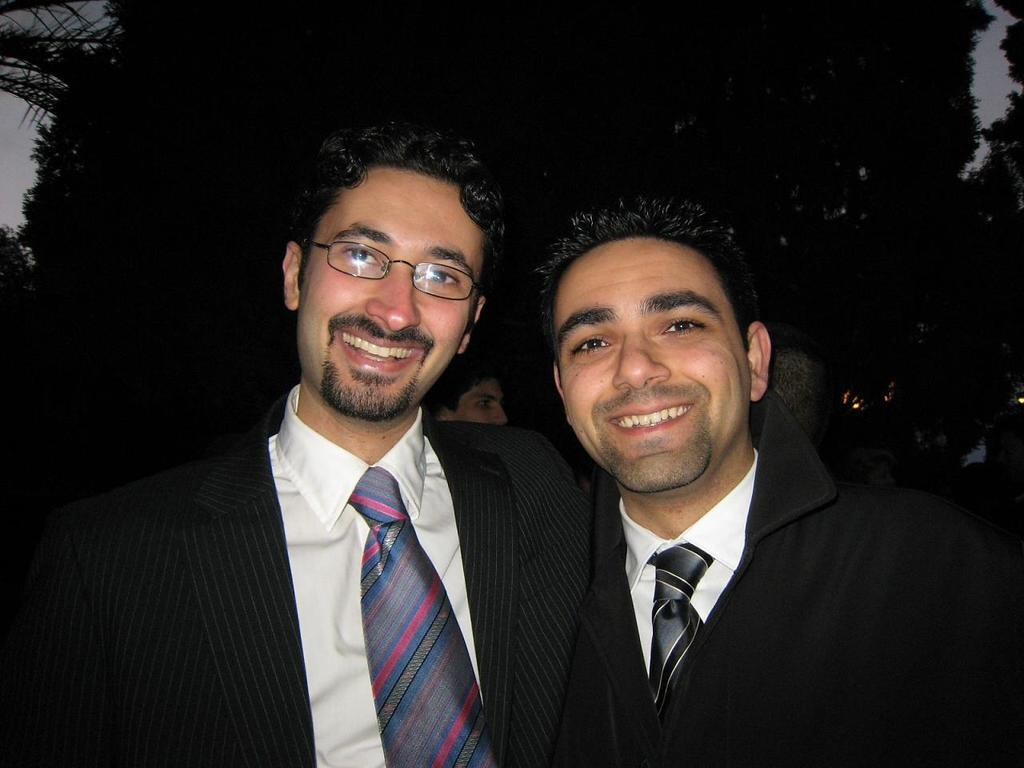Who or what is present in the image? There are people in the image. What is the facial expression of the people in the image? The people have smiling faces. What can be seen in the background of the image? There are trees in the background of the image. What type of powder is being used by the people in the image? There is no powder present in the image; the people have smiling faces and are not using any powder. 